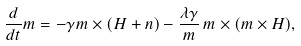<formula> <loc_0><loc_0><loc_500><loc_500>\frac { d } { d t } m = - \gamma m \times ( H + n ) - \frac { \lambda \gamma } { m } \, m \times ( m \times H ) ,</formula> 